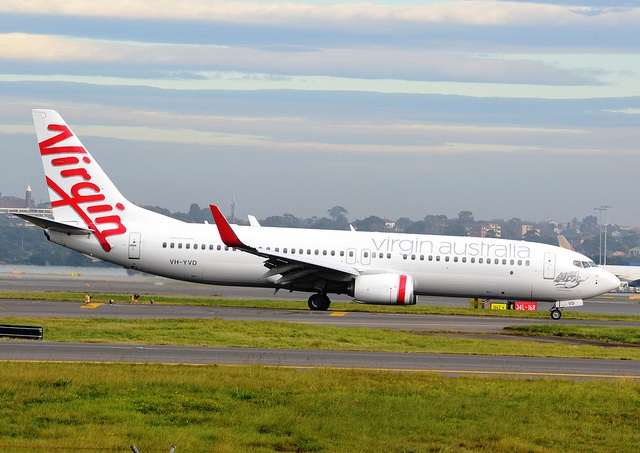Describe the objects in this image and their specific colors. I can see airplane in ivory, white, darkgray, black, and gray tones and airplane in ivory, lightgray, darkgray, and gray tones in this image. 